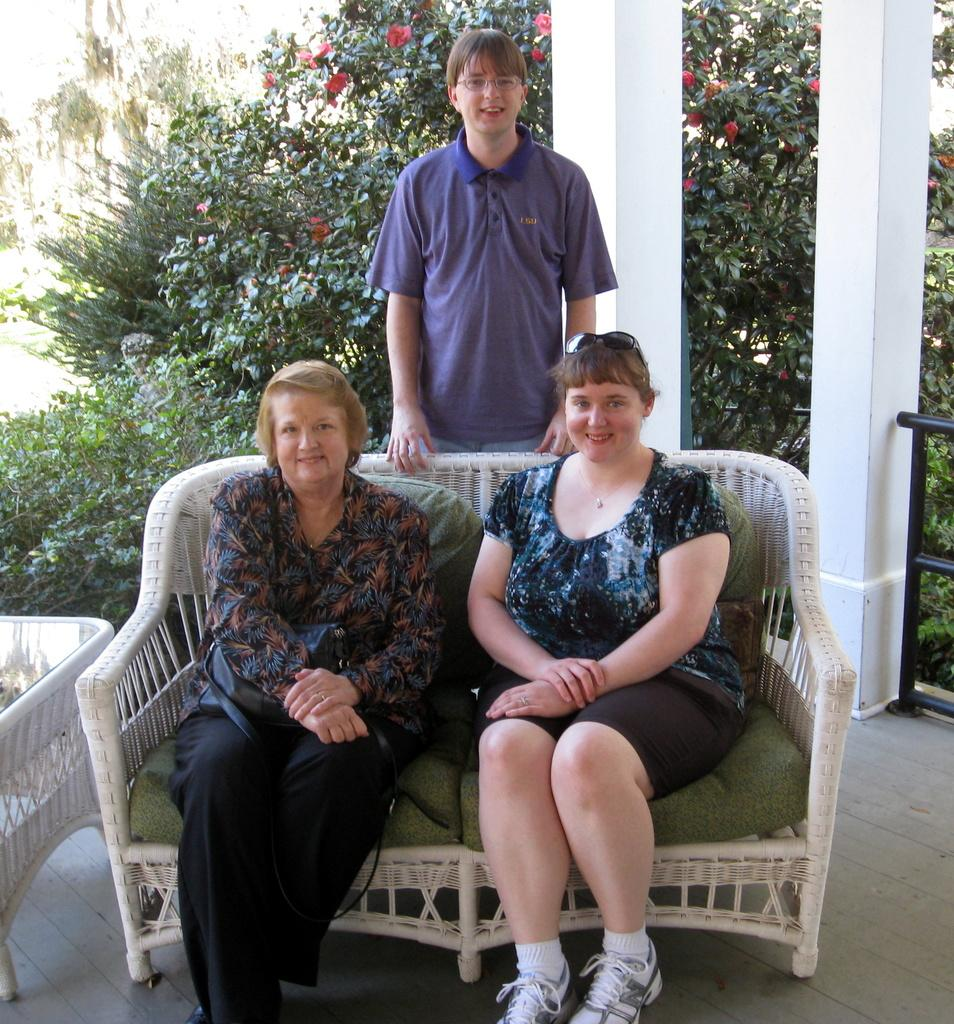How many people are sitting in the image? There are two women sitting on chairs in the image. What is the man in the image doing? There is a man standing in the image. What color is the man's T-shirt? The man is wearing a blue T-shirt. What can be seen in the background of the image? There are trees, plants, and pillars in the background of the image. What type of yam is being used as a prop in the image? There is no yam present in the image. What happens when the flag in the image bursts? There is no flag present in the image, so it cannot burst. 